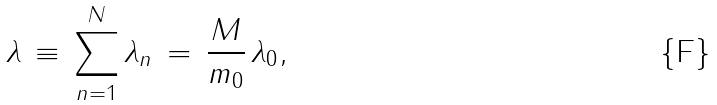Convert formula to latex. <formula><loc_0><loc_0><loc_500><loc_500>\lambda \, \equiv \, \sum _ { n = 1 } ^ { N } \lambda _ { n } \, = \, \frac { M } { m _ { 0 } } \, \lambda _ { 0 } ,</formula> 